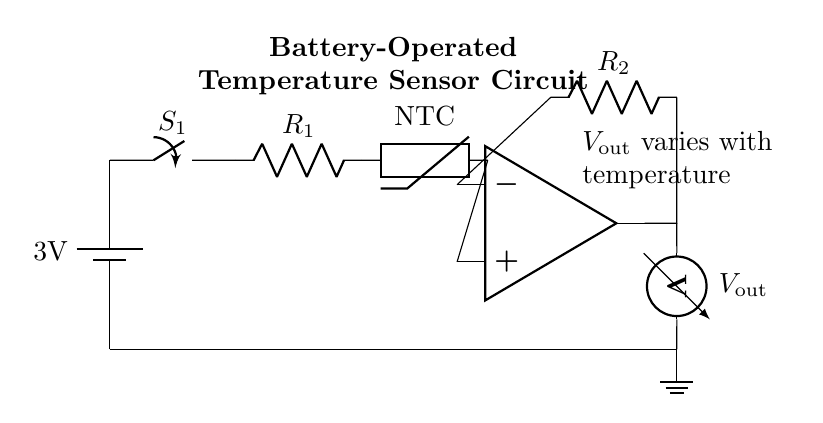What is the voltage of the battery in this circuit? The voltage is 3V, indicated by the label on the battery symbol in the circuit diagram.
Answer: 3V What type of temperature sensor is used in this circuit? The sensor is an NTC thermistor, as labeled in the circuit diagram. NTC stands for Negative Temperature Coefficient, implying its resistance decreases as temperature increases.
Answer: NTC What is the output element in this circuit? The output element is a voltmeter, denoted by the symbol and the label Vout in the circuit diagram. This component measures the output voltage that varies with the temperature.
Answer: Voltmeter What is the purpose of the switch in this circuit? The switch is used to control the flow of current in the circuit. When closed, it allows current to pass, thereby enabling the operation of the circuit including the sensor and other components.
Answer: Control current How does the output voltage relate to temperature? The output voltage Vout varies with temperature, which is a function of the resistance change in the NTC thermistor as temperature changes. As the temperature increases, the resistance decreases, affecting Vout.
Answer: Vout varies with temperature What is the role of the operational amplifier in this circuit? The operational amplifier amplifies the signal from the NTC thermistor, enhancing the ability to measure small changes in temperature accurately through its output voltage.
Answer: Amplifies signal 